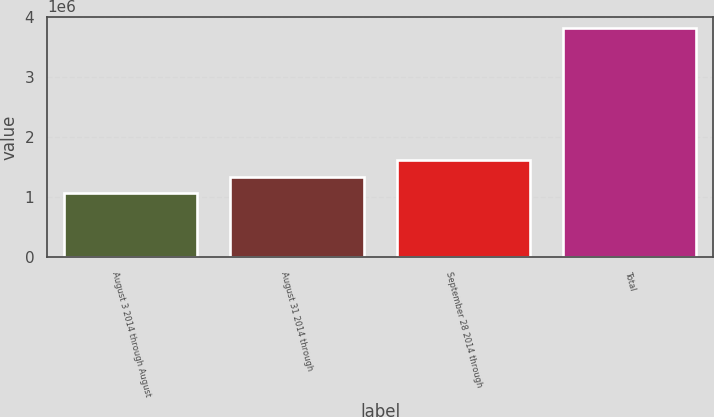Convert chart. <chart><loc_0><loc_0><loc_500><loc_500><bar_chart><fcel>August 3 2014 through August<fcel>August 31 2014 through<fcel>September 28 2014 through<fcel>Total<nl><fcel>1.0642e+06<fcel>1.33956e+06<fcel>1.61492e+06<fcel>3.8178e+06<nl></chart> 